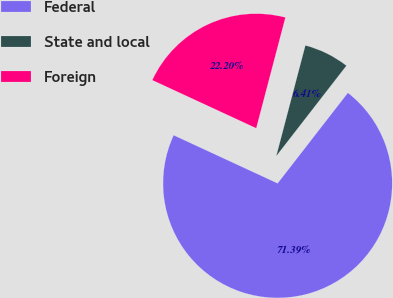Convert chart to OTSL. <chart><loc_0><loc_0><loc_500><loc_500><pie_chart><fcel>Federal<fcel>State and local<fcel>Foreign<nl><fcel>71.4%<fcel>6.41%<fcel>22.2%<nl></chart> 